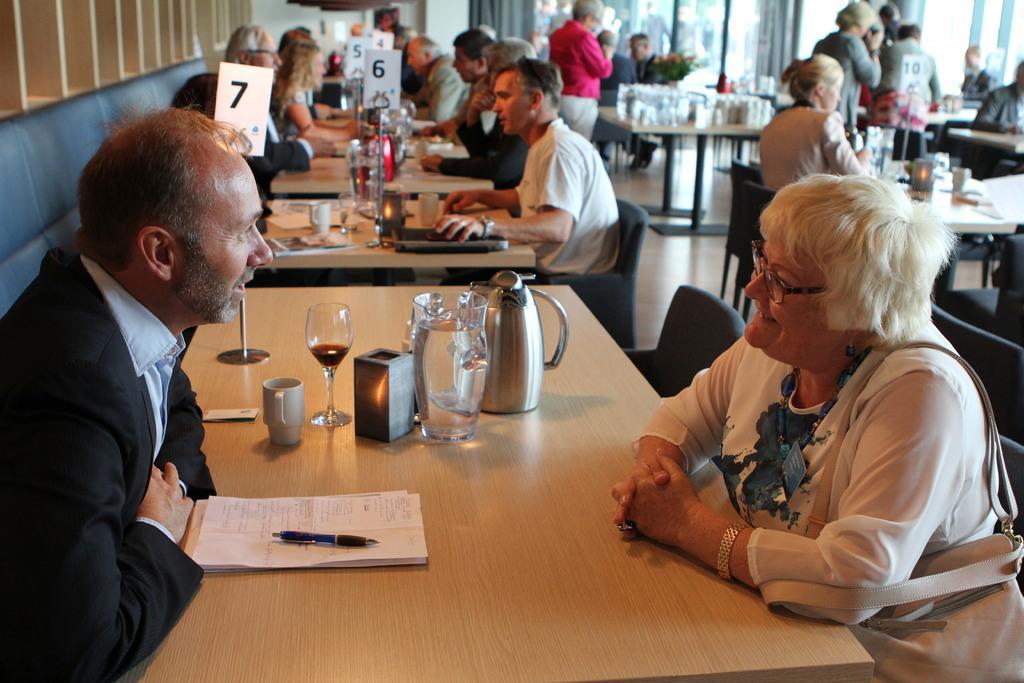Please provide a concise description of this image. In this image, there are some persons wearing clothes and sitting in front of the table. The table contains jugs, glass, cup, pen and some papers. The person who is on the right side of the image wearing spectacles on her head. 